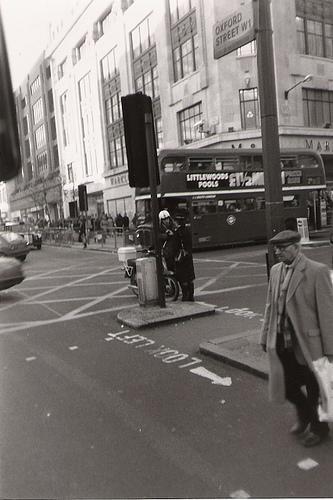How many decks does the bus have?
Give a very brief answer. 2. How many clock faces are visible?
Give a very brief answer. 0. 